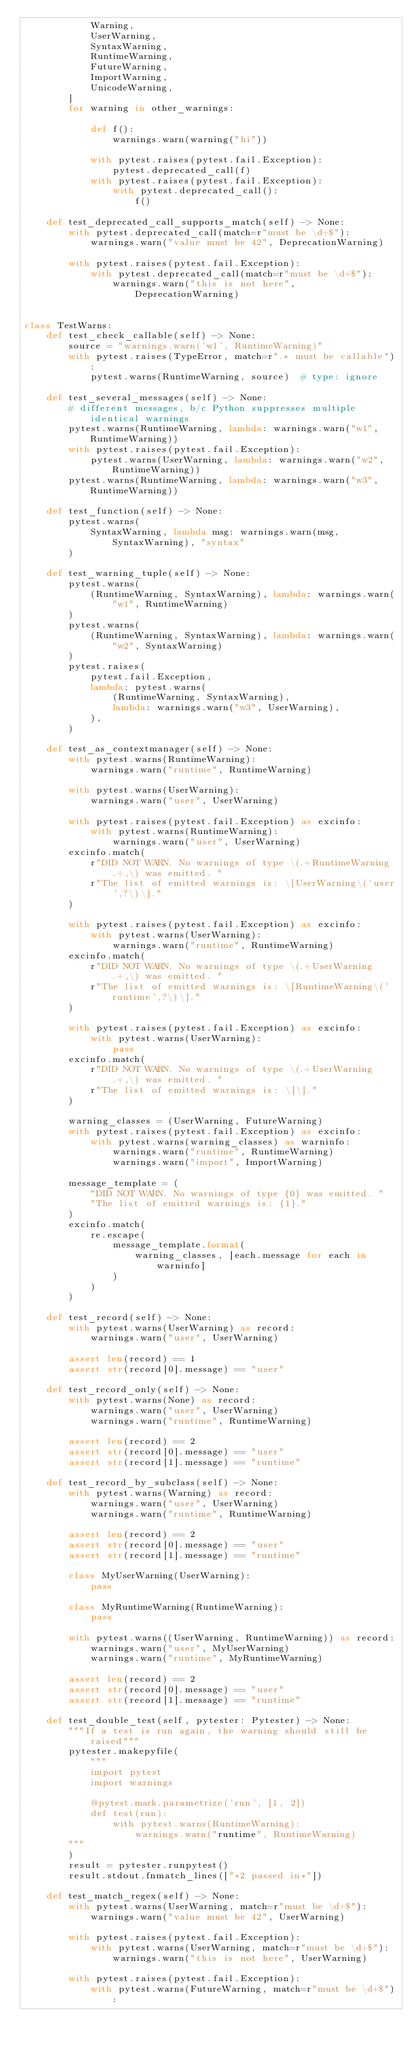Convert code to text. <code><loc_0><loc_0><loc_500><loc_500><_Python_>            Warning,
            UserWarning,
            SyntaxWarning,
            RuntimeWarning,
            FutureWarning,
            ImportWarning,
            UnicodeWarning,
        ]
        for warning in other_warnings:

            def f():
                warnings.warn(warning("hi"))

            with pytest.raises(pytest.fail.Exception):
                pytest.deprecated_call(f)
            with pytest.raises(pytest.fail.Exception):
                with pytest.deprecated_call():
                    f()

    def test_deprecated_call_supports_match(self) -> None:
        with pytest.deprecated_call(match=r"must be \d+$"):
            warnings.warn("value must be 42", DeprecationWarning)

        with pytest.raises(pytest.fail.Exception):
            with pytest.deprecated_call(match=r"must be \d+$"):
                warnings.warn("this is not here", DeprecationWarning)


class TestWarns:
    def test_check_callable(self) -> None:
        source = "warnings.warn('w1', RuntimeWarning)"
        with pytest.raises(TypeError, match=r".* must be callable"):
            pytest.warns(RuntimeWarning, source)  # type: ignore

    def test_several_messages(self) -> None:
        # different messages, b/c Python suppresses multiple identical warnings
        pytest.warns(RuntimeWarning, lambda: warnings.warn("w1", RuntimeWarning))
        with pytest.raises(pytest.fail.Exception):
            pytest.warns(UserWarning, lambda: warnings.warn("w2", RuntimeWarning))
        pytest.warns(RuntimeWarning, lambda: warnings.warn("w3", RuntimeWarning))

    def test_function(self) -> None:
        pytest.warns(
            SyntaxWarning, lambda msg: warnings.warn(msg, SyntaxWarning), "syntax"
        )

    def test_warning_tuple(self) -> None:
        pytest.warns(
            (RuntimeWarning, SyntaxWarning), lambda: warnings.warn("w1", RuntimeWarning)
        )
        pytest.warns(
            (RuntimeWarning, SyntaxWarning), lambda: warnings.warn("w2", SyntaxWarning)
        )
        pytest.raises(
            pytest.fail.Exception,
            lambda: pytest.warns(
                (RuntimeWarning, SyntaxWarning),
                lambda: warnings.warn("w3", UserWarning),
            ),
        )

    def test_as_contextmanager(self) -> None:
        with pytest.warns(RuntimeWarning):
            warnings.warn("runtime", RuntimeWarning)

        with pytest.warns(UserWarning):
            warnings.warn("user", UserWarning)

        with pytest.raises(pytest.fail.Exception) as excinfo:
            with pytest.warns(RuntimeWarning):
                warnings.warn("user", UserWarning)
        excinfo.match(
            r"DID NOT WARN. No warnings of type \(.+RuntimeWarning.+,\) was emitted. "
            r"The list of emitted warnings is: \[UserWarning\('user',?\)\]."
        )

        with pytest.raises(pytest.fail.Exception) as excinfo:
            with pytest.warns(UserWarning):
                warnings.warn("runtime", RuntimeWarning)
        excinfo.match(
            r"DID NOT WARN. No warnings of type \(.+UserWarning.+,\) was emitted. "
            r"The list of emitted warnings is: \[RuntimeWarning\('runtime',?\)\]."
        )

        with pytest.raises(pytest.fail.Exception) as excinfo:
            with pytest.warns(UserWarning):
                pass
        excinfo.match(
            r"DID NOT WARN. No warnings of type \(.+UserWarning.+,\) was emitted. "
            r"The list of emitted warnings is: \[\]."
        )

        warning_classes = (UserWarning, FutureWarning)
        with pytest.raises(pytest.fail.Exception) as excinfo:
            with pytest.warns(warning_classes) as warninfo:
                warnings.warn("runtime", RuntimeWarning)
                warnings.warn("import", ImportWarning)

        message_template = (
            "DID NOT WARN. No warnings of type {0} was emitted. "
            "The list of emitted warnings is: {1}."
        )
        excinfo.match(
            re.escape(
                message_template.format(
                    warning_classes, [each.message for each in warninfo]
                )
            )
        )

    def test_record(self) -> None:
        with pytest.warns(UserWarning) as record:
            warnings.warn("user", UserWarning)

        assert len(record) == 1
        assert str(record[0].message) == "user"

    def test_record_only(self) -> None:
        with pytest.warns(None) as record:
            warnings.warn("user", UserWarning)
            warnings.warn("runtime", RuntimeWarning)

        assert len(record) == 2
        assert str(record[0].message) == "user"
        assert str(record[1].message) == "runtime"

    def test_record_by_subclass(self) -> None:
        with pytest.warns(Warning) as record:
            warnings.warn("user", UserWarning)
            warnings.warn("runtime", RuntimeWarning)

        assert len(record) == 2
        assert str(record[0].message) == "user"
        assert str(record[1].message) == "runtime"

        class MyUserWarning(UserWarning):
            pass

        class MyRuntimeWarning(RuntimeWarning):
            pass

        with pytest.warns((UserWarning, RuntimeWarning)) as record:
            warnings.warn("user", MyUserWarning)
            warnings.warn("runtime", MyRuntimeWarning)

        assert len(record) == 2
        assert str(record[0].message) == "user"
        assert str(record[1].message) == "runtime"

    def test_double_test(self, pytester: Pytester) -> None:
        """If a test is run again, the warning should still be raised"""
        pytester.makepyfile(
            """
            import pytest
            import warnings

            @pytest.mark.parametrize('run', [1, 2])
            def test(run):
                with pytest.warns(RuntimeWarning):
                    warnings.warn("runtime", RuntimeWarning)
        """
        )
        result = pytester.runpytest()
        result.stdout.fnmatch_lines(["*2 passed in*"])

    def test_match_regex(self) -> None:
        with pytest.warns(UserWarning, match=r"must be \d+$"):
            warnings.warn("value must be 42", UserWarning)

        with pytest.raises(pytest.fail.Exception):
            with pytest.warns(UserWarning, match=r"must be \d+$"):
                warnings.warn("this is not here", UserWarning)

        with pytest.raises(pytest.fail.Exception):
            with pytest.warns(FutureWarning, match=r"must be \d+$"):</code> 